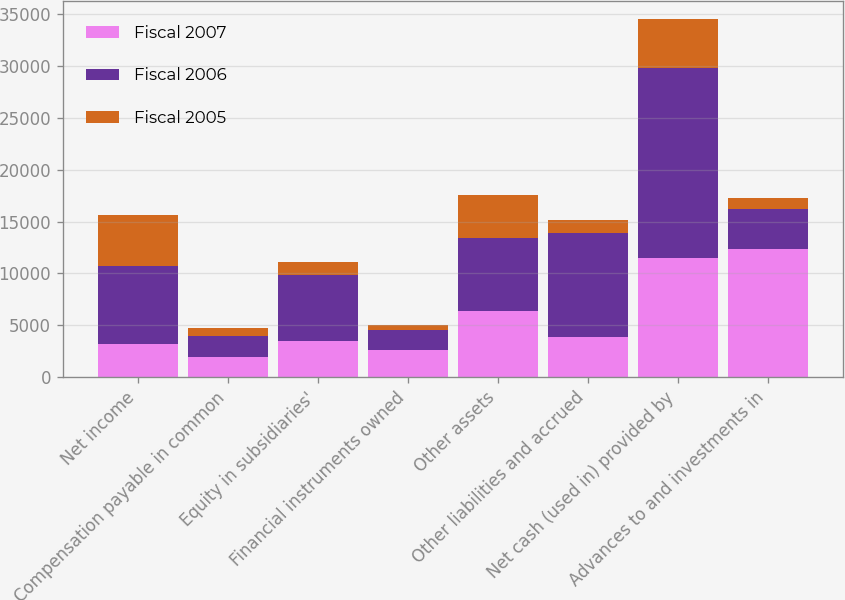Convert chart to OTSL. <chart><loc_0><loc_0><loc_500><loc_500><stacked_bar_chart><ecel><fcel>Net income<fcel>Compensation payable in common<fcel>Equity in subsidiaries'<fcel>Financial instruments owned<fcel>Other assets<fcel>Other liabilities and accrued<fcel>Net cash (used in) provided by<fcel>Advances to and investments in<nl><fcel>Fiscal 2007<fcel>3209<fcel>1941<fcel>3500<fcel>2625<fcel>6346<fcel>3811.5<fcel>11484<fcel>12376<nl><fcel>Fiscal 2006<fcel>7472<fcel>1955<fcel>6345<fcel>1857<fcel>7091<fcel>10064<fcel>18380<fcel>3811.5<nl><fcel>Fiscal 2005<fcel>4939<fcel>836<fcel>1269<fcel>554<fcel>4123<fcel>1255<fcel>4681<fcel>1044<nl></chart> 